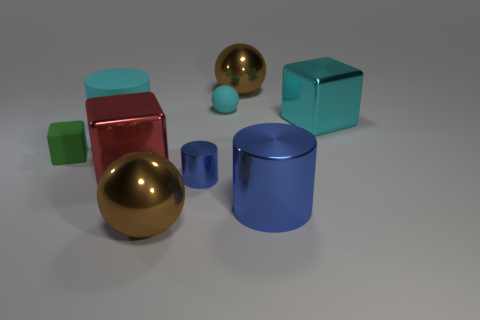Are there an equal number of tiny objects on the left side of the big red metallic block and blue cylinders?
Make the answer very short. No. What is the material of the brown thing that is in front of the large brown sphere that is behind the object that is to the left of the large cyan cylinder?
Give a very brief answer. Metal. There is a metal sphere that is in front of the small sphere; what color is it?
Offer a very short reply. Brown. There is a matte thing that is on the right side of the big brown ball in front of the large red shiny thing; what is its size?
Your answer should be very brief. Small. Is the number of blue metal cylinders on the left side of the red block the same as the number of big blue shiny cylinders that are behind the big blue cylinder?
Your answer should be compact. Yes. There is another cylinder that is the same material as the small cylinder; what color is it?
Offer a terse response. Blue. Do the red cube and the small ball right of the big red block have the same material?
Your response must be concise. No. The rubber object that is both on the left side of the small cylinder and behind the rubber block is what color?
Keep it short and to the point. Cyan. How many cubes are small green objects or small things?
Provide a succinct answer. 1. There is a small blue thing; does it have the same shape as the small rubber thing that is behind the small green rubber block?
Your answer should be very brief. No. 